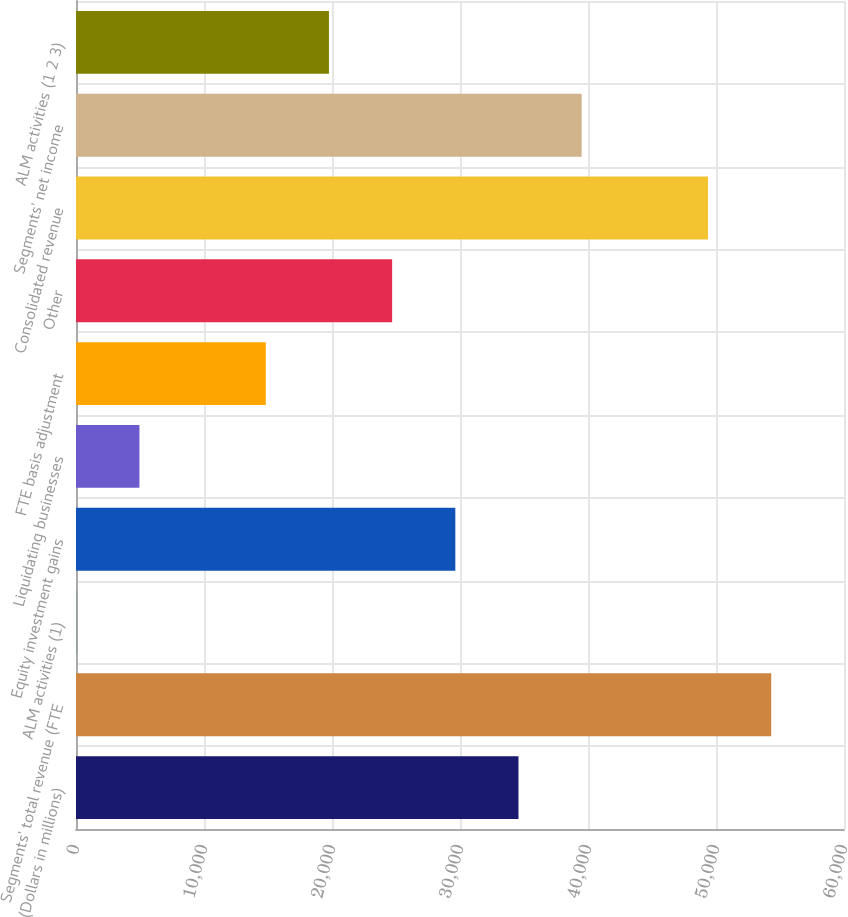<chart> <loc_0><loc_0><loc_500><loc_500><bar_chart><fcel>(Dollars in millions)<fcel>Segments' total revenue (FTE<fcel>ALM activities (1)<fcel>Equity investment gains<fcel>Liquidating businesses<fcel>FTE basis adjustment<fcel>Other<fcel>Consolidated revenue<fcel>Segments' net income<fcel>ALM activities (1 2 3)<nl><fcel>34569.9<fcel>54312.7<fcel>20<fcel>29634.2<fcel>4955.7<fcel>14827.1<fcel>24698.5<fcel>49377<fcel>39505.6<fcel>19762.8<nl></chart> 